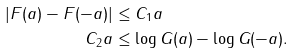<formula> <loc_0><loc_0><loc_500><loc_500>| F ( a ) - F ( - a ) | & \leq C _ { 1 } a \\ C _ { 2 } a & \leq \log G ( a ) - \log G ( - a ) .</formula> 